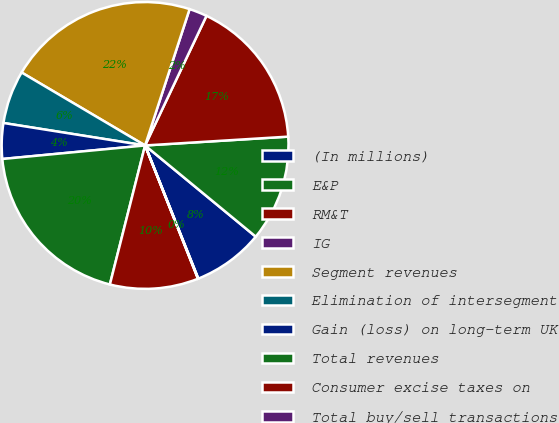Convert chart to OTSL. <chart><loc_0><loc_0><loc_500><loc_500><pie_chart><fcel>(In millions)<fcel>E&P<fcel>RM&T<fcel>IG<fcel>Segment revenues<fcel>Elimination of intersegment<fcel>Gain (loss) on long-term UK<fcel>Total revenues<fcel>Consumer excise taxes on<fcel>Total buy/sell transactions<nl><fcel>7.98%<fcel>11.95%<fcel>16.98%<fcel>2.02%<fcel>21.53%<fcel>5.99%<fcel>4.01%<fcel>19.55%<fcel>9.96%<fcel>0.04%<nl></chart> 